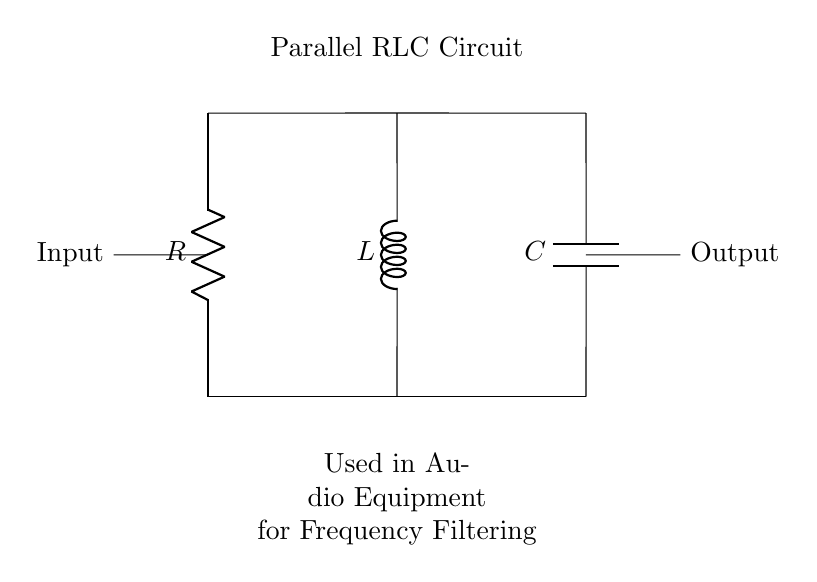What components are in this circuit? The components are a resistor, inductor, and capacitor, which are clearly labeled in the circuit diagram.
Answer: Resistor, inductor, capacitor What type of circuit is displayed? The diagram represents a parallel RLC circuit, which is indicated by both the configuration and the labels within the circuit.
Answer: Parallel RLC circuit What is the purpose of the circuit? The circuit is used for frequency filtering in audio equipment, as described in the additional text below the circuit.
Answer: Frequency filtering What happens to a high-frequency signal in this circuit? In a parallel RLC circuit, high-frequency signals are typically shunted to ground, which results in attenuation of those frequencies, thus filtering them out.
Answer: Attenuation of high frequencies How does the inductor behave at low frequencies? The inductor presents a low impedance at low frequencies, allowing low-frequency signals to pass through effectively while filtering out higher frequencies.
Answer: Low impedance How is the output taken from the circuit? The output is taken across the capacitor, and since the capacitor in a parallel RLC circuit allows signals at its resonant frequency to pass, this explains the placement of the output node.
Answer: Across the capacitor 